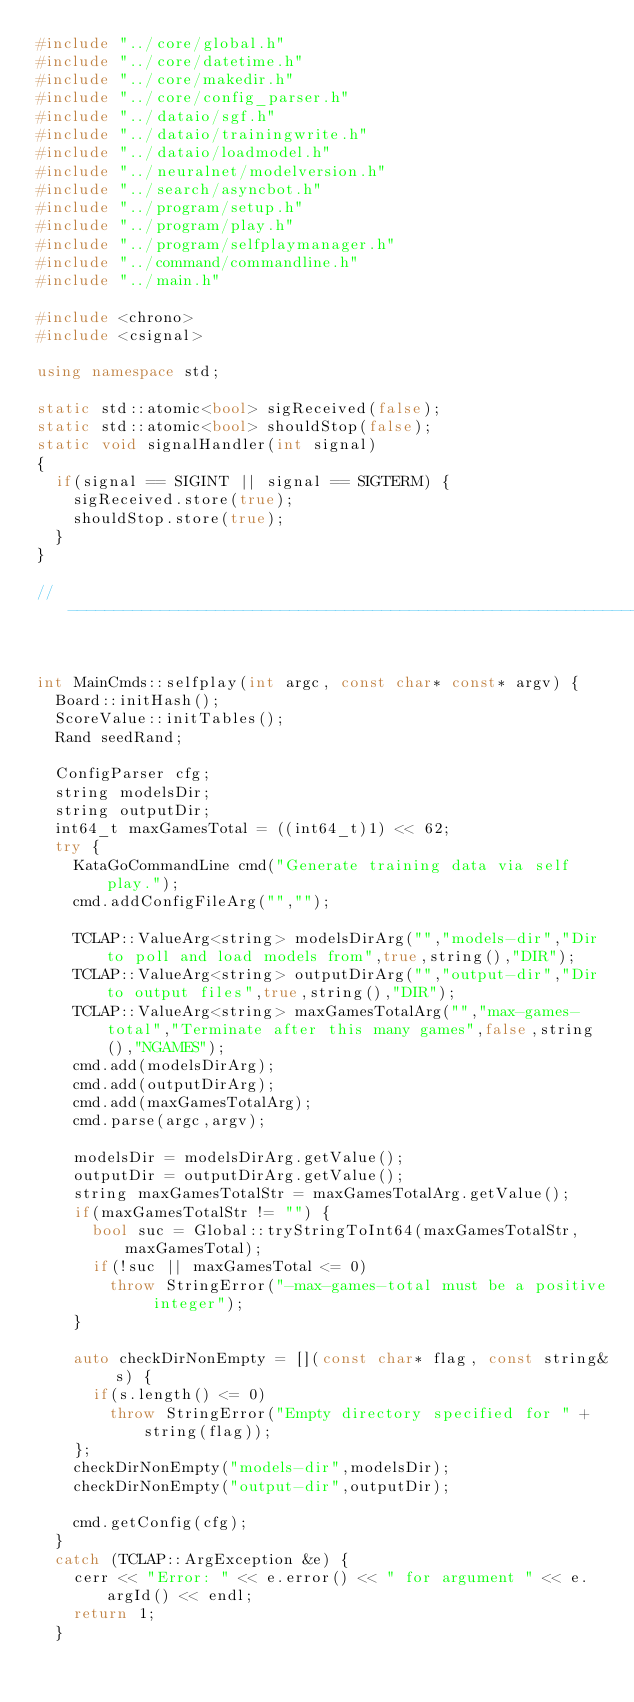Convert code to text. <code><loc_0><loc_0><loc_500><loc_500><_C++_>#include "../core/global.h"
#include "../core/datetime.h"
#include "../core/makedir.h"
#include "../core/config_parser.h"
#include "../dataio/sgf.h"
#include "../dataio/trainingwrite.h"
#include "../dataio/loadmodel.h"
#include "../neuralnet/modelversion.h"
#include "../search/asyncbot.h"
#include "../program/setup.h"
#include "../program/play.h"
#include "../program/selfplaymanager.h"
#include "../command/commandline.h"
#include "../main.h"

#include <chrono>
#include <csignal>

using namespace std;

static std::atomic<bool> sigReceived(false);
static std::atomic<bool> shouldStop(false);
static void signalHandler(int signal)
{
  if(signal == SIGINT || signal == SIGTERM) {
    sigReceived.store(true);
    shouldStop.store(true);
  }
}

//-----------------------------------------------------------------------------------------


int MainCmds::selfplay(int argc, const char* const* argv) {
  Board::initHash();
  ScoreValue::initTables();
  Rand seedRand;

  ConfigParser cfg;
  string modelsDir;
  string outputDir;
  int64_t maxGamesTotal = ((int64_t)1) << 62;
  try {
    KataGoCommandLine cmd("Generate training data via self play.");
    cmd.addConfigFileArg("","");

    TCLAP::ValueArg<string> modelsDirArg("","models-dir","Dir to poll and load models from",true,string(),"DIR");
    TCLAP::ValueArg<string> outputDirArg("","output-dir","Dir to output files",true,string(),"DIR");
    TCLAP::ValueArg<string> maxGamesTotalArg("","max-games-total","Terminate after this many games",false,string(),"NGAMES");
    cmd.add(modelsDirArg);
    cmd.add(outputDirArg);
    cmd.add(maxGamesTotalArg);
    cmd.parse(argc,argv);

    modelsDir = modelsDirArg.getValue();
    outputDir = outputDirArg.getValue();
    string maxGamesTotalStr = maxGamesTotalArg.getValue();
    if(maxGamesTotalStr != "") {
      bool suc = Global::tryStringToInt64(maxGamesTotalStr,maxGamesTotal);
      if(!suc || maxGamesTotal <= 0)
        throw StringError("-max-games-total must be a positive integer");
    }

    auto checkDirNonEmpty = [](const char* flag, const string& s) {
      if(s.length() <= 0)
        throw StringError("Empty directory specified for " + string(flag));
    };
    checkDirNonEmpty("models-dir",modelsDir);
    checkDirNonEmpty("output-dir",outputDir);

    cmd.getConfig(cfg);
  }
  catch (TCLAP::ArgException &e) {
    cerr << "Error: " << e.error() << " for argument " << e.argId() << endl;
    return 1;
  }
</code> 